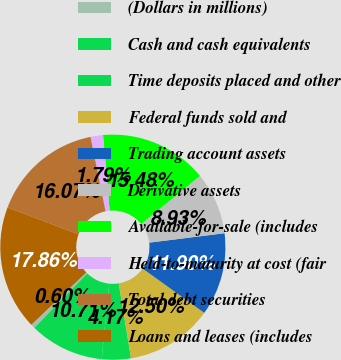<chart> <loc_0><loc_0><loc_500><loc_500><pie_chart><fcel>(Dollars in millions)<fcel>Cash and cash equivalents<fcel>Time deposits placed and other<fcel>Federal funds sold and<fcel>Trading account assets<fcel>Derivative assets<fcel>Available-for-sale (includes<fcel>Held-to-maturity at cost (fair<fcel>Total debt securities<fcel>Loans and leases (includes<nl><fcel>0.6%<fcel>10.71%<fcel>4.17%<fcel>12.5%<fcel>11.9%<fcel>8.93%<fcel>15.48%<fcel>1.79%<fcel>16.07%<fcel>17.86%<nl></chart> 